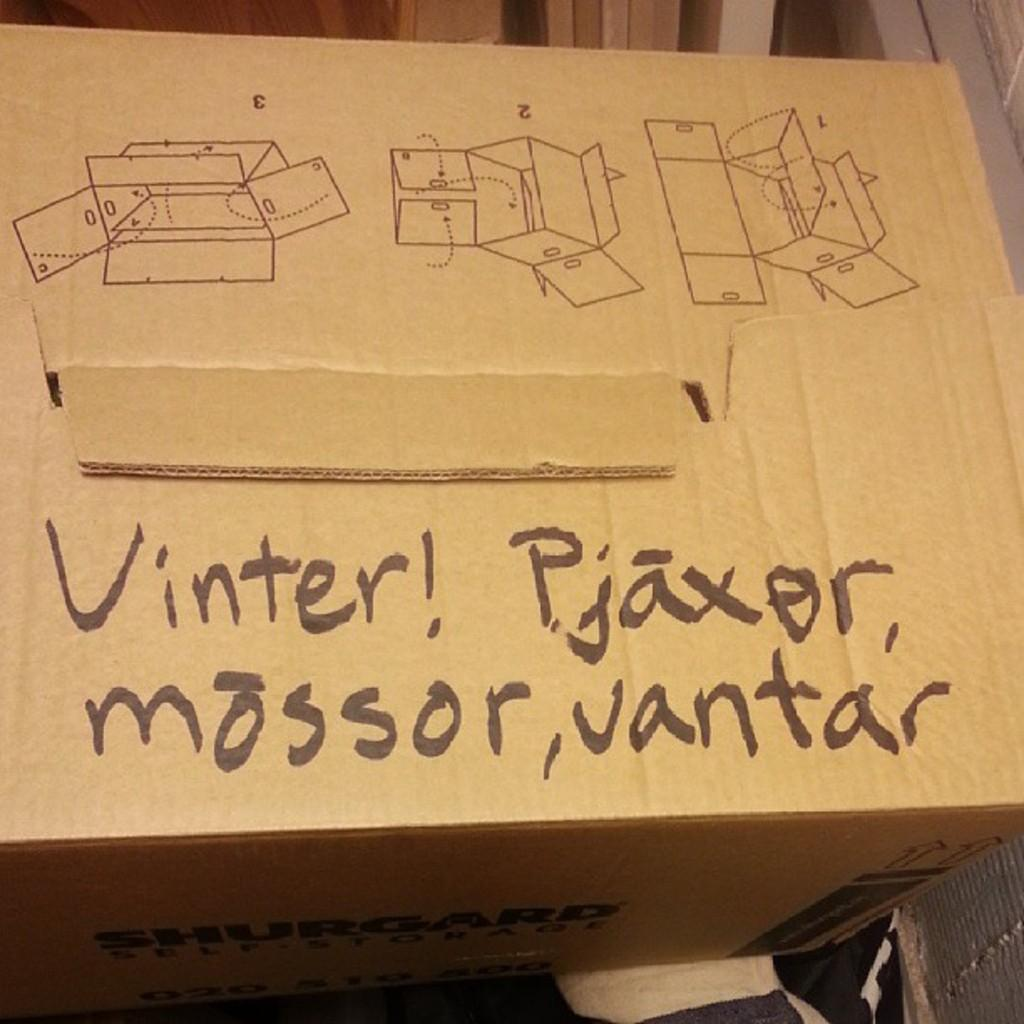Provide a one-sentence caption for the provided image. A cardboard box has the words "Vinter! Pjaxor, Mossor, Vantar" written on the top. 